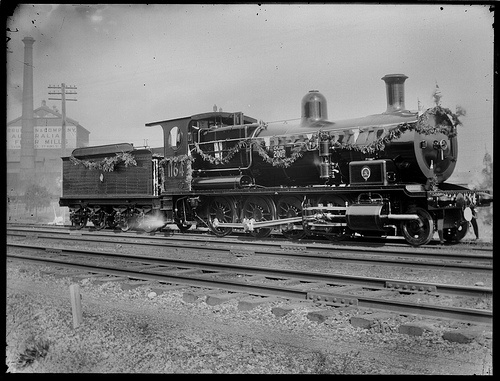Describe the objects in this image and their specific colors. I can see a train in gray, black, darkgray, and lightgray tones in this image. 